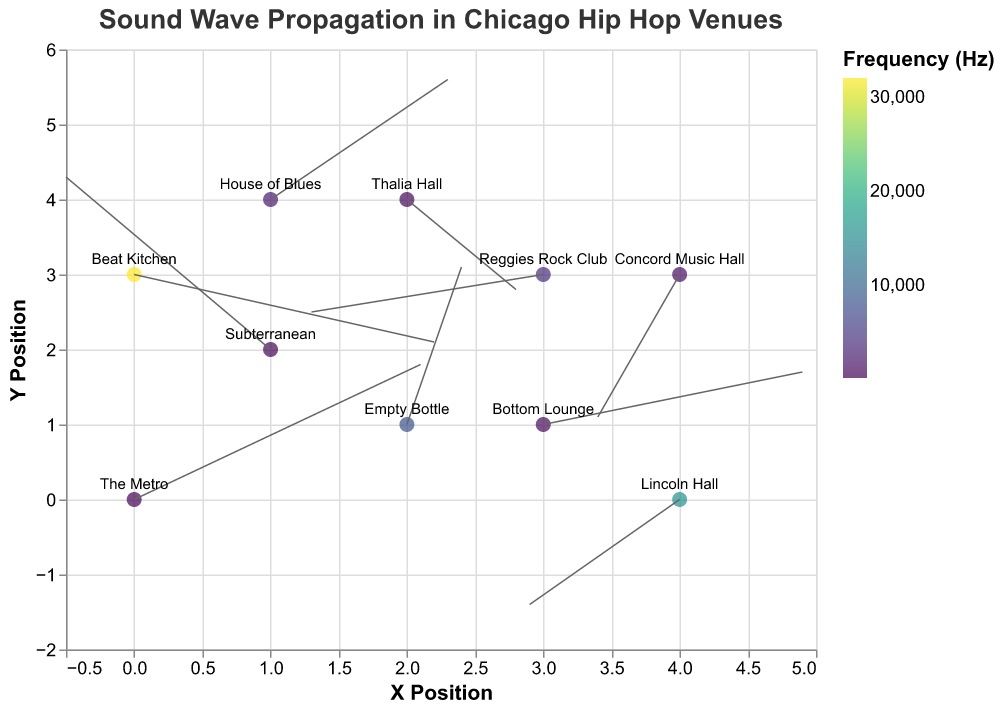What is the title of the figure? The title of the figure is displayed at the top and reads "Sound Wave Propagation in Chicago Hip Hop Venues".
Answer: Sound Wave Propagation in Chicago Hip Hop Venues How many hip hop venues are represented in the figure? Each point represents a venue, and there are 10 points in total in the figure, corresponding to 10 venues.
Answer: 10 Which venue has the highest frequency? Using the color scale labeled "Frequency (Hz)", the color corresponding to the highest frequency value is observed at "Beat Kitchen".
Answer: Beat Kitchen Which venue has the most vectors (u, v) traveling primarily in the negative x and negative y directions? By observing the direction of the vectors, Concord Music Hall and Lincoln Hall have vectors predominantly in both negative x and negative y directions.
Answer: Concord Music Hall and Lincoln Hall What are the frequency values of House of Blues and Reggies Rock Club, and which one is higher? House of Blues has a frequency of 2000 Hz, and Reggies Rock Club has a frequency of 4000 Hz. Comparing these, Reggies Rock Club has the higher frequency.
Answer: Reggies Rock Club What is the total distance covered by the vector at Subterranean? The vector direction is given by (u, v), and at Subterranean, it is (-1.5, 2.3). The distance is √((-1.5)^2 + (2.3)^2). √(2.25 + 5.29) = √7.54 ≈ 2.75
Answer: 2.75 Which venue has a vector pointing almost directly up (positive y direction) and what is its frequency? By looking at the directions of the vectors, Empty Bottle has a vector pointing almost directly up with coordinates (0.4, 2.1), and its frequency is 8000 Hz.
Answer: Empty Bottle, 8000 Hz For venues Bottom Lounge and Concord Music Hall, compare their vector lengths and identify which length is longer. Bottom Lounge vector length is √((1.9)^2 + (0.7)^2) = √(3.61 + 0.49) = √4.10 ≈ 2.02. Concord Music Hall vector length is √((-0.6)^2 + (-1.9)^2) = √(0.36 + 3.61) = √3.97 ≈ 1.99. Bottom Lounge has the longer vector length.
Answer: Bottom Lounge Which venue's vector has the largest magnitude among all? Calculate each vector's magnitude and compare: √((2.1)^2 + (1.8)^2) = 2.76 (The Metro), Subterranean (2.75), Thalia Hall (1.44), Bottom Lounge (2.02), Concord Music Hall (1.99), House of Blues (2.05), Reggies Rock Club (1.77), Empty Bottle (2.13), Lincoln Hall (1.78), Beat Kitchen (2.38). The largest vector magnitude is at The Metro.
Answer: The Metro 